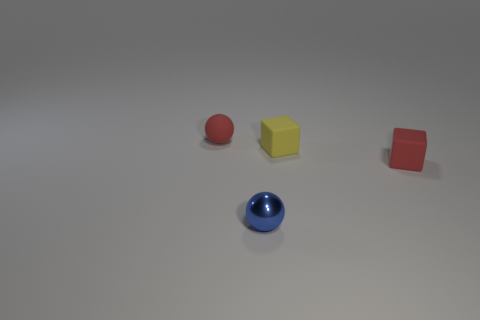Is there any significance to the arrangement of the objects? The objects are arranged with adequate space between them, which might suggest an intentional display for comparison of colors, shapes, or materials. The specific arrangement may also be purely aesthetic or random, and without additional context, it's difficult to ascertain any deeper significance. 